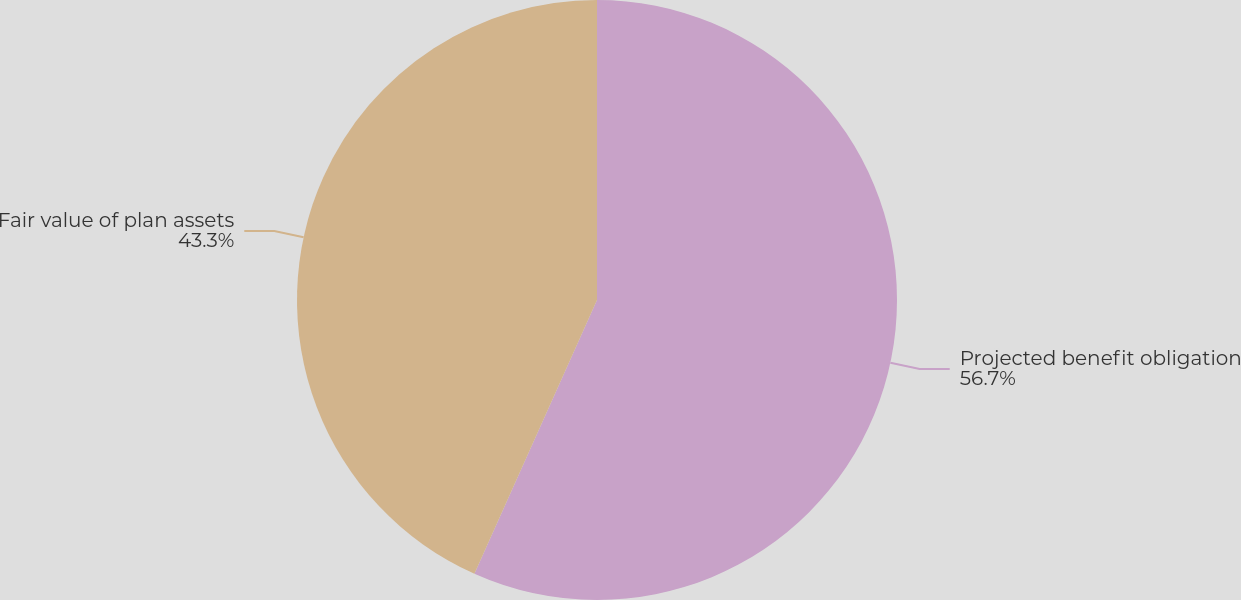<chart> <loc_0><loc_0><loc_500><loc_500><pie_chart><fcel>Projected benefit obligation<fcel>Fair value of plan assets<nl><fcel>56.7%<fcel>43.3%<nl></chart> 